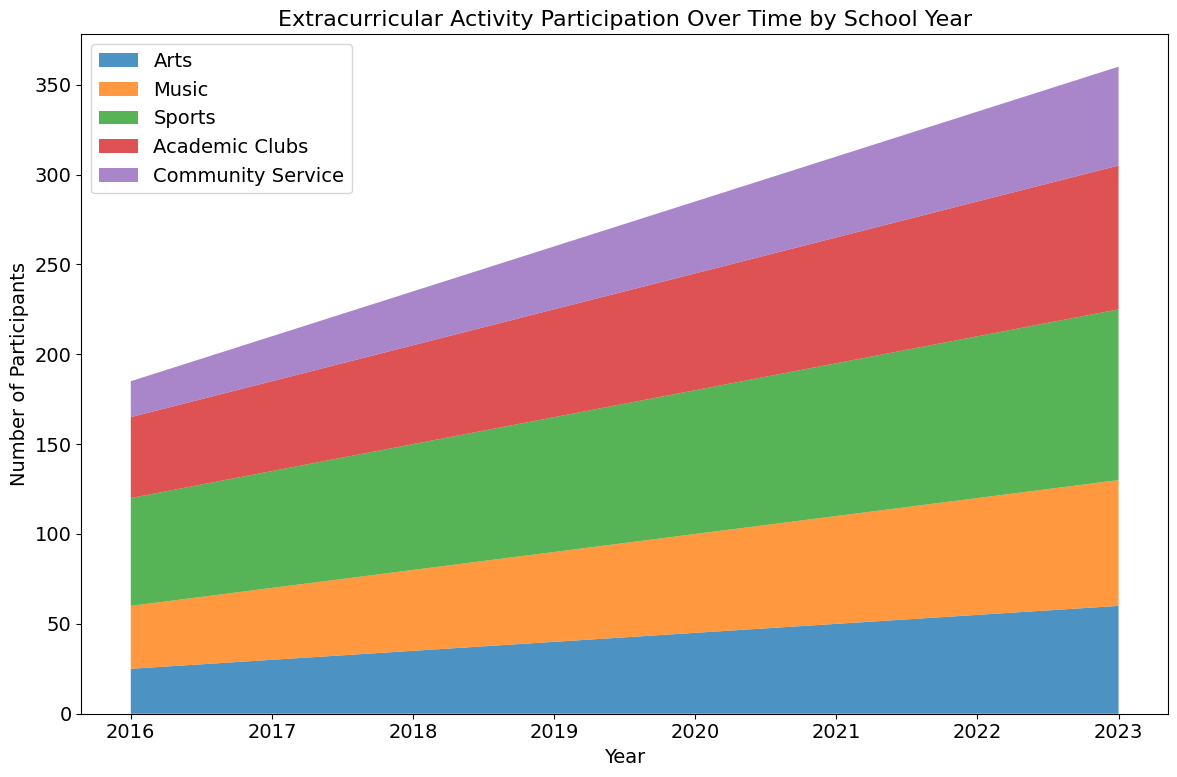Which year had the highest participation in Sports? First, identify the "Sports" area in the chart, which has a distinct color. Track this area across the years and find the year at which it peaks.
Answer: 2023 Did the Music participation increase steadily over the years? By observing the "Music" area in the chart, note if it consistently grows taller each year.
Answer: Yes What's the average number of participants in Academic Clubs from 2016 to 2023? Sum the participants in Academic Clubs for each year and divide by the number of years: (45 + 50 + 55 + 60 + 65 + 70 + 75 + 80) / 8.
Answer: 62.5 In which year was the participation in Community Service equal to 30 participants? Locate the "Community Service" area on the chart and find the year where the value is 30.
Answer: 2018 Compare the number of participants in Arts in 2016 and 2023. How much higher was it in 2023? Refer to the "Arts" area in the chart for the years 2016 and 2023. Subtract the number of participants in 2016 from that in 2023: 60 - 25.
Answer: 35 What is the difference in the number of participants between Music and Academic Clubs in 2020? Find the values for Music and Academic Clubs in 2020 from the chart and subtract the latter from the former: 55 - 65.
Answer: -10 Which extracurricular activity showed the greatest increase in participation from 2016 to 2023? Calculate the difference in number of participants from 2016 to 2023 for each activity and identify the highest: (Arts: 60-25, Music: 70-35, Sports: 95-60, Academic Clubs: 80-45, Community Service: 55-20).
Answer: Sports Is there any year where the participation in Arts and Community Service combined equals the participation in Sports? Add the participants in Arts and Community Service for each year, then compare with the Sports participants of the same year.
Answer: No 